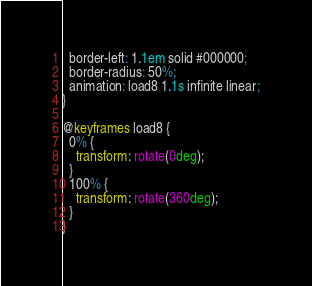<code> <loc_0><loc_0><loc_500><loc_500><_CSS_>  border-left: 1.1em solid #000000;
  border-radius: 50%;
  animation: load8 1.1s infinite linear;
}

@keyframes load8 {
  0% {
    transform: rotate(0deg);
  }
  100% {
    transform: rotate(360deg);
  }
}</code> 